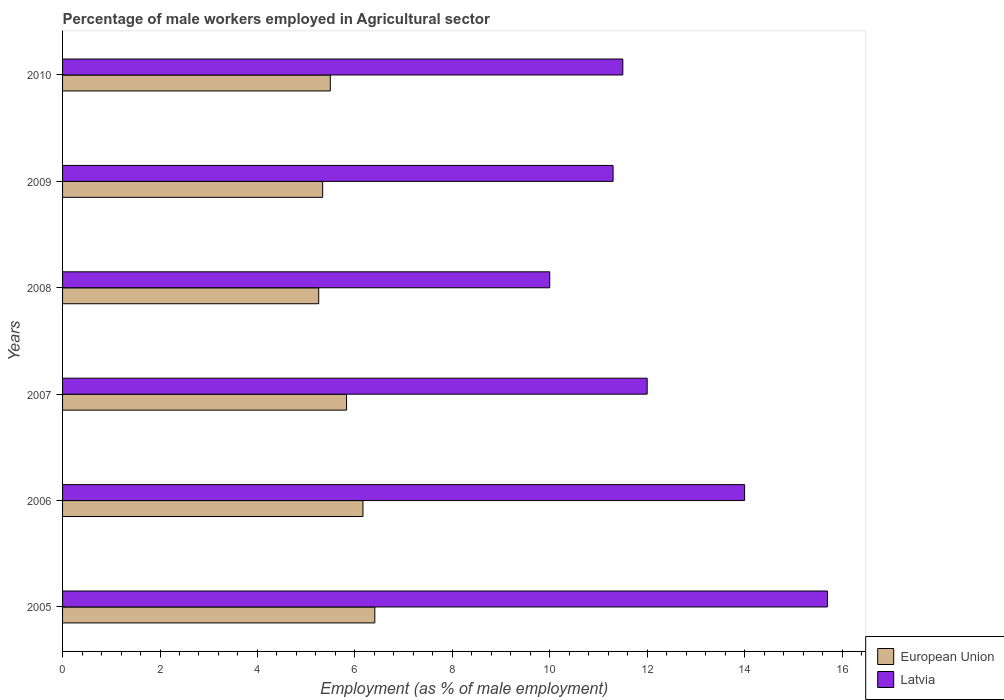How many different coloured bars are there?
Make the answer very short. 2. Are the number of bars per tick equal to the number of legend labels?
Provide a short and direct response. Yes. How many bars are there on the 4th tick from the bottom?
Ensure brevity in your answer.  2. Across all years, what is the maximum percentage of male workers employed in Agricultural sector in European Union?
Your answer should be compact. 6.41. In which year was the percentage of male workers employed in Agricultural sector in Latvia maximum?
Offer a very short reply. 2005. In which year was the percentage of male workers employed in Agricultural sector in European Union minimum?
Offer a terse response. 2008. What is the total percentage of male workers employed in Agricultural sector in European Union in the graph?
Provide a short and direct response. 34.5. What is the difference between the percentage of male workers employed in Agricultural sector in European Union in 2005 and that in 2010?
Offer a terse response. 0.91. What is the difference between the percentage of male workers employed in Agricultural sector in European Union in 2006 and the percentage of male workers employed in Agricultural sector in Latvia in 2009?
Provide a succinct answer. -5.13. What is the average percentage of male workers employed in Agricultural sector in Latvia per year?
Make the answer very short. 12.42. In the year 2008, what is the difference between the percentage of male workers employed in Agricultural sector in Latvia and percentage of male workers employed in Agricultural sector in European Union?
Offer a very short reply. 4.74. In how many years, is the percentage of male workers employed in Agricultural sector in European Union greater than 2.4 %?
Make the answer very short. 6. What is the ratio of the percentage of male workers employed in Agricultural sector in European Union in 2005 to that in 2007?
Your response must be concise. 1.1. Is the percentage of male workers employed in Agricultural sector in European Union in 2008 less than that in 2009?
Your response must be concise. Yes. Is the difference between the percentage of male workers employed in Agricultural sector in Latvia in 2006 and 2007 greater than the difference between the percentage of male workers employed in Agricultural sector in European Union in 2006 and 2007?
Ensure brevity in your answer.  Yes. What is the difference between the highest and the second highest percentage of male workers employed in Agricultural sector in European Union?
Make the answer very short. 0.24. What is the difference between the highest and the lowest percentage of male workers employed in Agricultural sector in European Union?
Your response must be concise. 1.15. In how many years, is the percentage of male workers employed in Agricultural sector in European Union greater than the average percentage of male workers employed in Agricultural sector in European Union taken over all years?
Your answer should be compact. 3. What does the 1st bar from the top in 2008 represents?
Provide a succinct answer. Latvia. What does the 1st bar from the bottom in 2008 represents?
Make the answer very short. European Union. How many bars are there?
Make the answer very short. 12. Are all the bars in the graph horizontal?
Make the answer very short. Yes. How many years are there in the graph?
Provide a short and direct response. 6. What is the difference between two consecutive major ticks on the X-axis?
Keep it short and to the point. 2. Are the values on the major ticks of X-axis written in scientific E-notation?
Ensure brevity in your answer.  No. What is the title of the graph?
Offer a very short reply. Percentage of male workers employed in Agricultural sector. What is the label or title of the X-axis?
Provide a succinct answer. Employment (as % of male employment). What is the label or title of the Y-axis?
Give a very brief answer. Years. What is the Employment (as % of male employment) in European Union in 2005?
Your response must be concise. 6.41. What is the Employment (as % of male employment) in Latvia in 2005?
Provide a short and direct response. 15.7. What is the Employment (as % of male employment) in European Union in 2006?
Your answer should be very brief. 6.17. What is the Employment (as % of male employment) in European Union in 2007?
Provide a short and direct response. 5.83. What is the Employment (as % of male employment) of European Union in 2008?
Ensure brevity in your answer.  5.26. What is the Employment (as % of male employment) in Latvia in 2008?
Provide a succinct answer. 10. What is the Employment (as % of male employment) of European Union in 2009?
Offer a terse response. 5.34. What is the Employment (as % of male employment) of Latvia in 2009?
Offer a terse response. 11.3. What is the Employment (as % of male employment) of European Union in 2010?
Keep it short and to the point. 5.5. Across all years, what is the maximum Employment (as % of male employment) in European Union?
Offer a terse response. 6.41. Across all years, what is the maximum Employment (as % of male employment) of Latvia?
Give a very brief answer. 15.7. Across all years, what is the minimum Employment (as % of male employment) of European Union?
Make the answer very short. 5.26. Across all years, what is the minimum Employment (as % of male employment) in Latvia?
Provide a short and direct response. 10. What is the total Employment (as % of male employment) in European Union in the graph?
Provide a succinct answer. 34.5. What is the total Employment (as % of male employment) in Latvia in the graph?
Your answer should be compact. 74.5. What is the difference between the Employment (as % of male employment) in European Union in 2005 and that in 2006?
Ensure brevity in your answer.  0.24. What is the difference between the Employment (as % of male employment) of Latvia in 2005 and that in 2006?
Offer a terse response. 1.7. What is the difference between the Employment (as % of male employment) of European Union in 2005 and that in 2007?
Provide a succinct answer. 0.58. What is the difference between the Employment (as % of male employment) in Latvia in 2005 and that in 2007?
Your answer should be very brief. 3.7. What is the difference between the Employment (as % of male employment) in European Union in 2005 and that in 2008?
Your answer should be compact. 1.15. What is the difference between the Employment (as % of male employment) of European Union in 2005 and that in 2009?
Your response must be concise. 1.07. What is the difference between the Employment (as % of male employment) of Latvia in 2005 and that in 2009?
Ensure brevity in your answer.  4.4. What is the difference between the Employment (as % of male employment) in European Union in 2005 and that in 2010?
Provide a short and direct response. 0.91. What is the difference between the Employment (as % of male employment) of Latvia in 2005 and that in 2010?
Your answer should be compact. 4.2. What is the difference between the Employment (as % of male employment) of European Union in 2006 and that in 2007?
Your answer should be compact. 0.34. What is the difference between the Employment (as % of male employment) of Latvia in 2006 and that in 2007?
Provide a succinct answer. 2. What is the difference between the Employment (as % of male employment) of European Union in 2006 and that in 2008?
Your response must be concise. 0.91. What is the difference between the Employment (as % of male employment) of European Union in 2006 and that in 2009?
Your answer should be compact. 0.83. What is the difference between the Employment (as % of male employment) of Latvia in 2006 and that in 2009?
Offer a terse response. 2.7. What is the difference between the Employment (as % of male employment) in European Union in 2006 and that in 2010?
Your answer should be compact. 0.67. What is the difference between the Employment (as % of male employment) of European Union in 2007 and that in 2008?
Provide a succinct answer. 0.57. What is the difference between the Employment (as % of male employment) of European Union in 2007 and that in 2009?
Offer a terse response. 0.49. What is the difference between the Employment (as % of male employment) of Latvia in 2007 and that in 2010?
Give a very brief answer. 0.5. What is the difference between the Employment (as % of male employment) in European Union in 2008 and that in 2009?
Your answer should be compact. -0.08. What is the difference between the Employment (as % of male employment) in Latvia in 2008 and that in 2009?
Your answer should be very brief. -1.3. What is the difference between the Employment (as % of male employment) of European Union in 2008 and that in 2010?
Keep it short and to the point. -0.24. What is the difference between the Employment (as % of male employment) of Latvia in 2008 and that in 2010?
Keep it short and to the point. -1.5. What is the difference between the Employment (as % of male employment) of European Union in 2009 and that in 2010?
Make the answer very short. -0.16. What is the difference between the Employment (as % of male employment) of Latvia in 2009 and that in 2010?
Your answer should be very brief. -0.2. What is the difference between the Employment (as % of male employment) in European Union in 2005 and the Employment (as % of male employment) in Latvia in 2006?
Your response must be concise. -7.59. What is the difference between the Employment (as % of male employment) of European Union in 2005 and the Employment (as % of male employment) of Latvia in 2007?
Keep it short and to the point. -5.59. What is the difference between the Employment (as % of male employment) of European Union in 2005 and the Employment (as % of male employment) of Latvia in 2008?
Ensure brevity in your answer.  -3.59. What is the difference between the Employment (as % of male employment) of European Union in 2005 and the Employment (as % of male employment) of Latvia in 2009?
Offer a terse response. -4.89. What is the difference between the Employment (as % of male employment) of European Union in 2005 and the Employment (as % of male employment) of Latvia in 2010?
Keep it short and to the point. -5.09. What is the difference between the Employment (as % of male employment) in European Union in 2006 and the Employment (as % of male employment) in Latvia in 2007?
Make the answer very short. -5.83. What is the difference between the Employment (as % of male employment) in European Union in 2006 and the Employment (as % of male employment) in Latvia in 2008?
Make the answer very short. -3.83. What is the difference between the Employment (as % of male employment) in European Union in 2006 and the Employment (as % of male employment) in Latvia in 2009?
Make the answer very short. -5.13. What is the difference between the Employment (as % of male employment) in European Union in 2006 and the Employment (as % of male employment) in Latvia in 2010?
Keep it short and to the point. -5.33. What is the difference between the Employment (as % of male employment) of European Union in 2007 and the Employment (as % of male employment) of Latvia in 2008?
Your answer should be compact. -4.17. What is the difference between the Employment (as % of male employment) of European Union in 2007 and the Employment (as % of male employment) of Latvia in 2009?
Keep it short and to the point. -5.47. What is the difference between the Employment (as % of male employment) in European Union in 2007 and the Employment (as % of male employment) in Latvia in 2010?
Ensure brevity in your answer.  -5.67. What is the difference between the Employment (as % of male employment) in European Union in 2008 and the Employment (as % of male employment) in Latvia in 2009?
Offer a very short reply. -6.04. What is the difference between the Employment (as % of male employment) of European Union in 2008 and the Employment (as % of male employment) of Latvia in 2010?
Make the answer very short. -6.24. What is the difference between the Employment (as % of male employment) in European Union in 2009 and the Employment (as % of male employment) in Latvia in 2010?
Provide a succinct answer. -6.16. What is the average Employment (as % of male employment) in European Union per year?
Provide a succinct answer. 5.75. What is the average Employment (as % of male employment) in Latvia per year?
Your answer should be compact. 12.42. In the year 2005, what is the difference between the Employment (as % of male employment) of European Union and Employment (as % of male employment) of Latvia?
Your answer should be very brief. -9.29. In the year 2006, what is the difference between the Employment (as % of male employment) in European Union and Employment (as % of male employment) in Latvia?
Ensure brevity in your answer.  -7.83. In the year 2007, what is the difference between the Employment (as % of male employment) of European Union and Employment (as % of male employment) of Latvia?
Your answer should be compact. -6.17. In the year 2008, what is the difference between the Employment (as % of male employment) of European Union and Employment (as % of male employment) of Latvia?
Your response must be concise. -4.74. In the year 2009, what is the difference between the Employment (as % of male employment) of European Union and Employment (as % of male employment) of Latvia?
Offer a terse response. -5.96. In the year 2010, what is the difference between the Employment (as % of male employment) of European Union and Employment (as % of male employment) of Latvia?
Your answer should be compact. -6. What is the ratio of the Employment (as % of male employment) of European Union in 2005 to that in 2006?
Keep it short and to the point. 1.04. What is the ratio of the Employment (as % of male employment) in Latvia in 2005 to that in 2006?
Keep it short and to the point. 1.12. What is the ratio of the Employment (as % of male employment) of European Union in 2005 to that in 2007?
Your answer should be compact. 1.1. What is the ratio of the Employment (as % of male employment) of Latvia in 2005 to that in 2007?
Keep it short and to the point. 1.31. What is the ratio of the Employment (as % of male employment) of European Union in 2005 to that in 2008?
Offer a very short reply. 1.22. What is the ratio of the Employment (as % of male employment) of Latvia in 2005 to that in 2008?
Provide a short and direct response. 1.57. What is the ratio of the Employment (as % of male employment) of European Union in 2005 to that in 2009?
Provide a succinct answer. 1.2. What is the ratio of the Employment (as % of male employment) of Latvia in 2005 to that in 2009?
Provide a succinct answer. 1.39. What is the ratio of the Employment (as % of male employment) in European Union in 2005 to that in 2010?
Your answer should be compact. 1.17. What is the ratio of the Employment (as % of male employment) of Latvia in 2005 to that in 2010?
Give a very brief answer. 1.37. What is the ratio of the Employment (as % of male employment) of European Union in 2006 to that in 2007?
Your answer should be very brief. 1.06. What is the ratio of the Employment (as % of male employment) in European Union in 2006 to that in 2008?
Your response must be concise. 1.17. What is the ratio of the Employment (as % of male employment) in European Union in 2006 to that in 2009?
Keep it short and to the point. 1.15. What is the ratio of the Employment (as % of male employment) of Latvia in 2006 to that in 2009?
Offer a very short reply. 1.24. What is the ratio of the Employment (as % of male employment) of European Union in 2006 to that in 2010?
Offer a terse response. 1.12. What is the ratio of the Employment (as % of male employment) of Latvia in 2006 to that in 2010?
Your response must be concise. 1.22. What is the ratio of the Employment (as % of male employment) in European Union in 2007 to that in 2008?
Provide a short and direct response. 1.11. What is the ratio of the Employment (as % of male employment) in Latvia in 2007 to that in 2008?
Ensure brevity in your answer.  1.2. What is the ratio of the Employment (as % of male employment) of European Union in 2007 to that in 2009?
Your answer should be very brief. 1.09. What is the ratio of the Employment (as % of male employment) of Latvia in 2007 to that in 2009?
Make the answer very short. 1.06. What is the ratio of the Employment (as % of male employment) of European Union in 2007 to that in 2010?
Ensure brevity in your answer.  1.06. What is the ratio of the Employment (as % of male employment) of Latvia in 2007 to that in 2010?
Your answer should be very brief. 1.04. What is the ratio of the Employment (as % of male employment) in European Union in 2008 to that in 2009?
Offer a very short reply. 0.98. What is the ratio of the Employment (as % of male employment) in Latvia in 2008 to that in 2009?
Provide a succinct answer. 0.89. What is the ratio of the Employment (as % of male employment) in European Union in 2008 to that in 2010?
Your response must be concise. 0.96. What is the ratio of the Employment (as % of male employment) of Latvia in 2008 to that in 2010?
Give a very brief answer. 0.87. What is the ratio of the Employment (as % of male employment) of European Union in 2009 to that in 2010?
Make the answer very short. 0.97. What is the ratio of the Employment (as % of male employment) in Latvia in 2009 to that in 2010?
Your answer should be very brief. 0.98. What is the difference between the highest and the second highest Employment (as % of male employment) in European Union?
Your answer should be very brief. 0.24. What is the difference between the highest and the second highest Employment (as % of male employment) in Latvia?
Your answer should be very brief. 1.7. What is the difference between the highest and the lowest Employment (as % of male employment) of European Union?
Give a very brief answer. 1.15. 